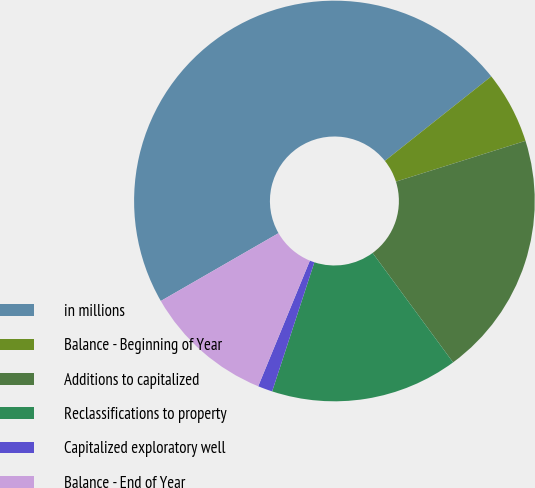Convert chart. <chart><loc_0><loc_0><loc_500><loc_500><pie_chart><fcel>in millions<fcel>Balance - Beginning of Year<fcel>Additions to capitalized<fcel>Reclassifications to property<fcel>Capitalized exploratory well<fcel>Balance - End of Year<nl><fcel>47.63%<fcel>5.83%<fcel>19.76%<fcel>15.12%<fcel>1.18%<fcel>10.47%<nl></chart> 